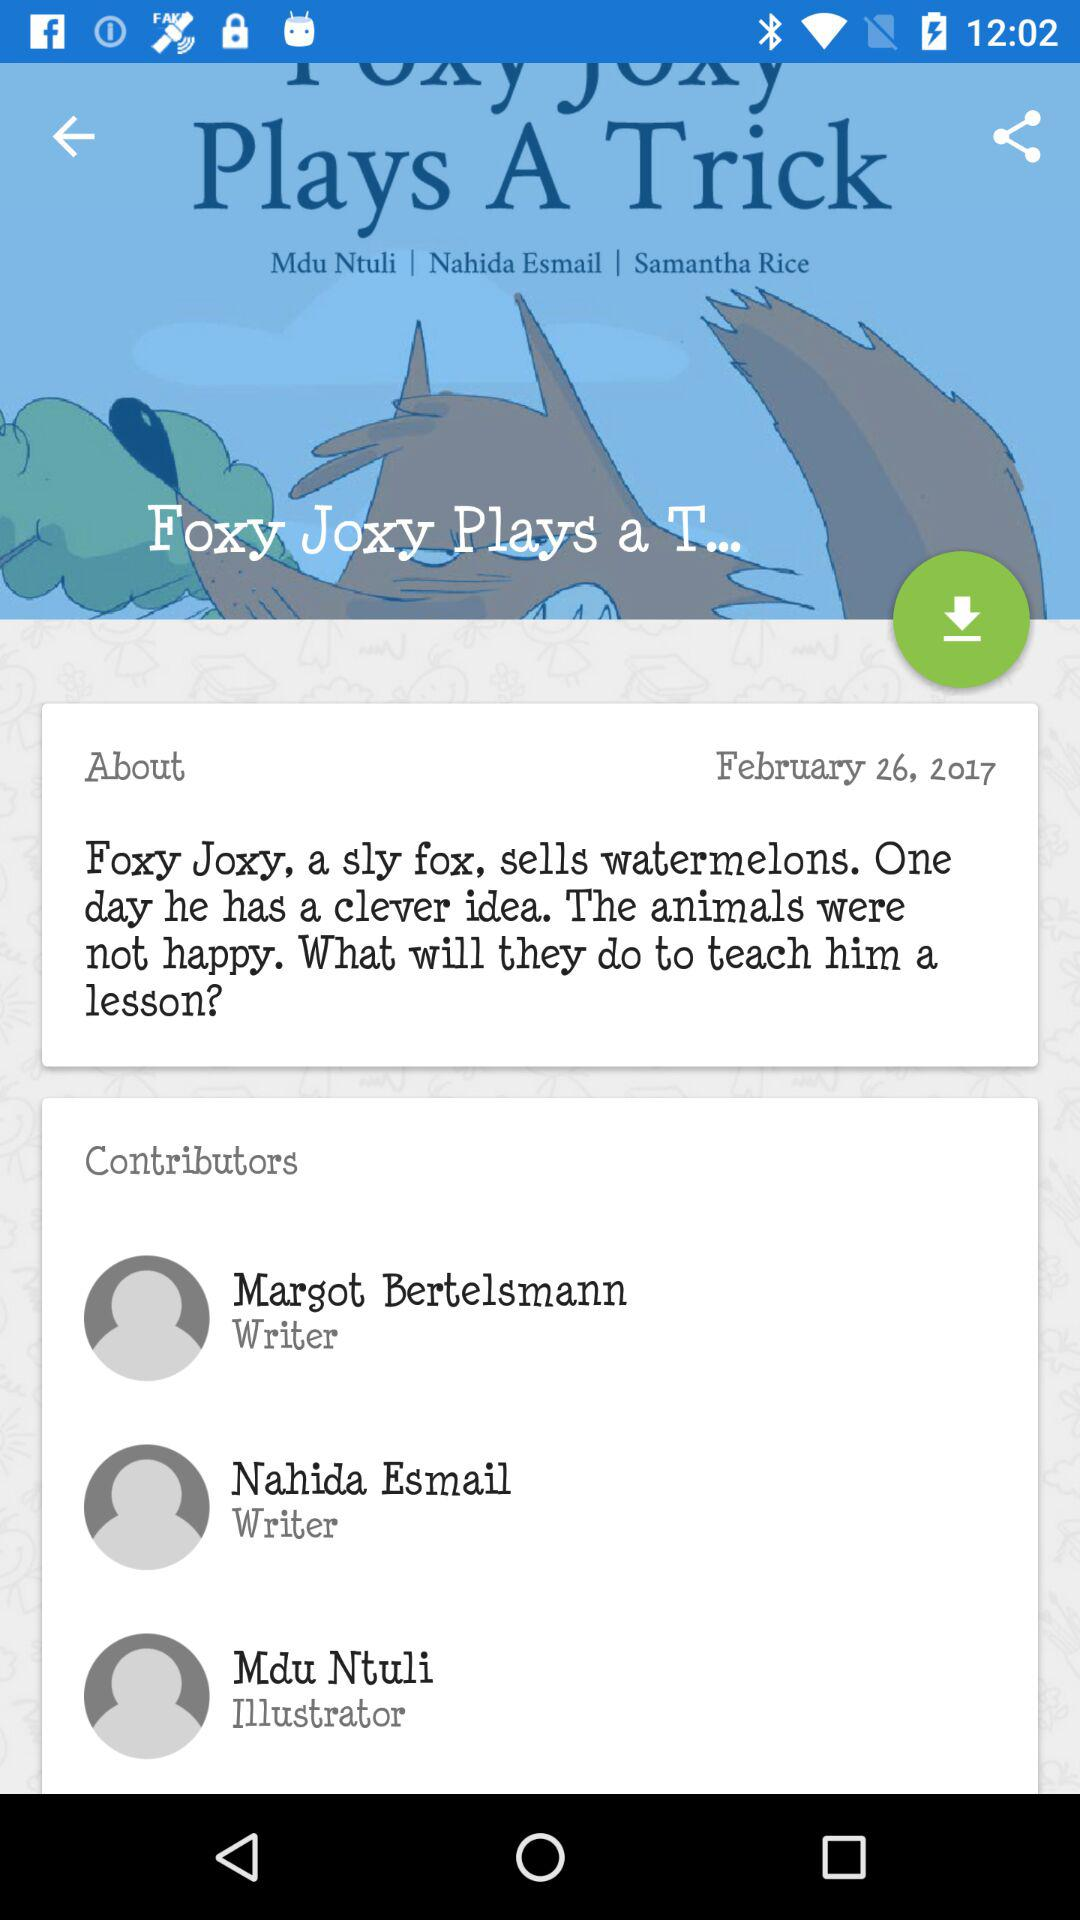Who is the writer? The writer is Nahida Esmail. 